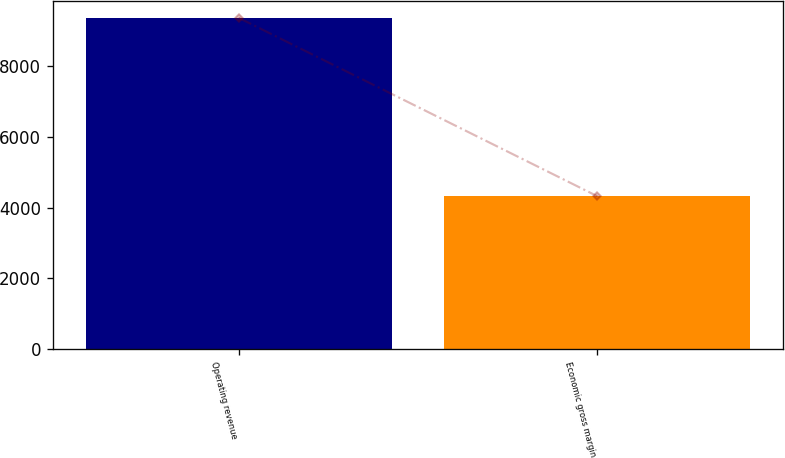Convert chart to OTSL. <chart><loc_0><loc_0><loc_500><loc_500><bar_chart><fcel>Operating revenue<fcel>Economic gross margin<nl><fcel>9377<fcel>4327<nl></chart> 